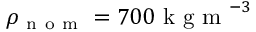Convert formula to latex. <formula><loc_0><loc_0><loc_500><loc_500>\rho _ { n o m } = 7 0 0 k g m ^ { - 3 }</formula> 